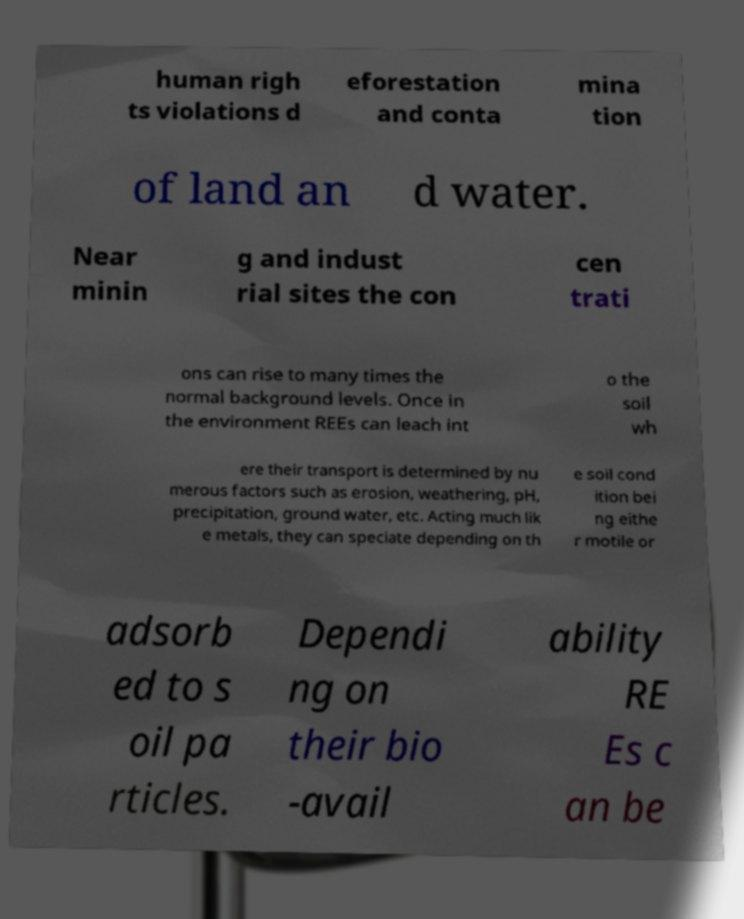Please read and relay the text visible in this image. What does it say? human righ ts violations d eforestation and conta mina tion of land an d water. Near minin g and indust rial sites the con cen trati ons can rise to many times the normal background levels. Once in the environment REEs can leach int o the soil wh ere their transport is determined by nu merous factors such as erosion, weathering, pH, precipitation, ground water, etc. Acting much lik e metals, they can speciate depending on th e soil cond ition bei ng eithe r motile or adsorb ed to s oil pa rticles. Dependi ng on their bio -avail ability RE Es c an be 